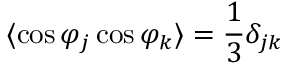<formula> <loc_0><loc_0><loc_500><loc_500>\langle \cos \varphi _ { j } \cos \varphi _ { k } \rangle = \frac { 1 } { 3 } \delta _ { j k }</formula> 